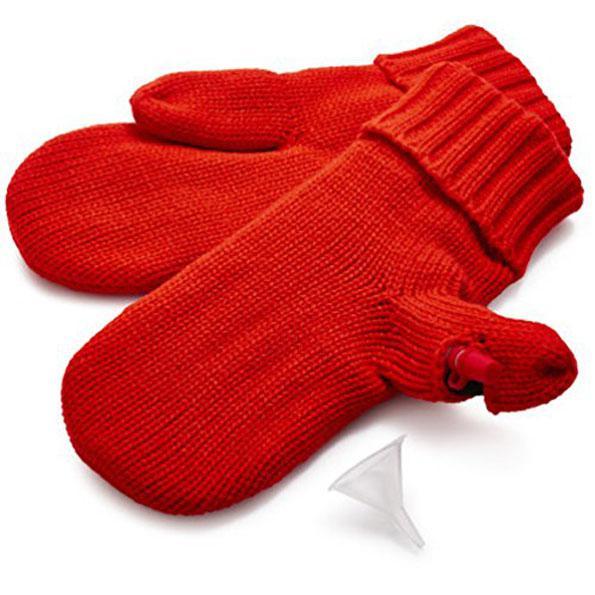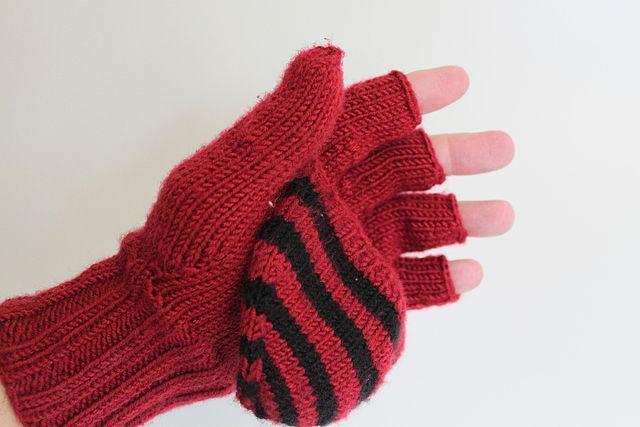The first image is the image on the left, the second image is the image on the right. Considering the images on both sides, is "One of the images shows at least one pair of gloves without any hands in them." valid? Answer yes or no. Yes. The first image is the image on the left, the second image is the image on the right. For the images displayed, is the sentence "An image shows a pair of hands in joined red mittens that form a heart shape when worn." factually correct? Answer yes or no. No. 